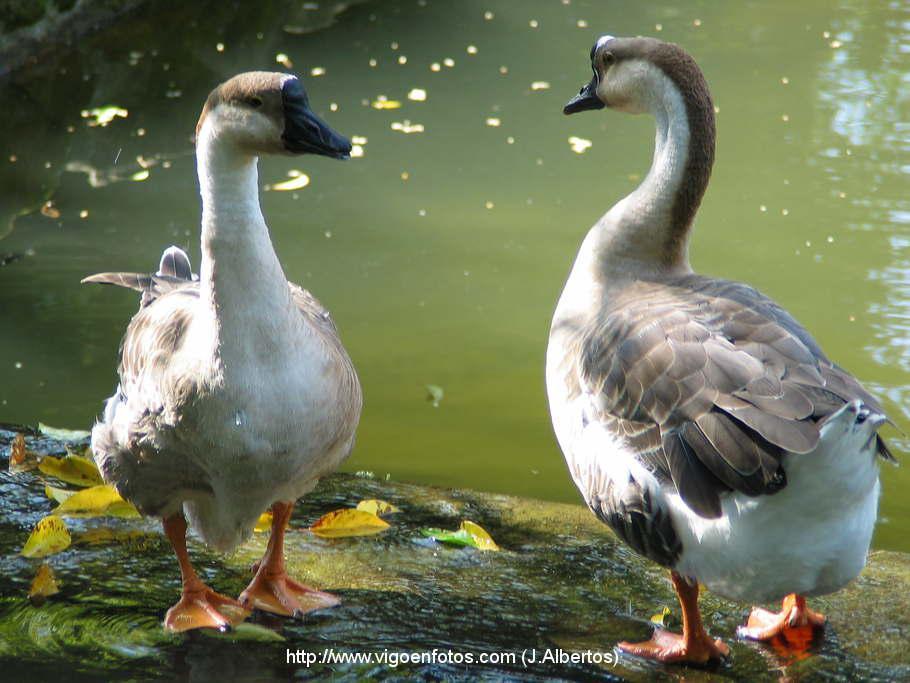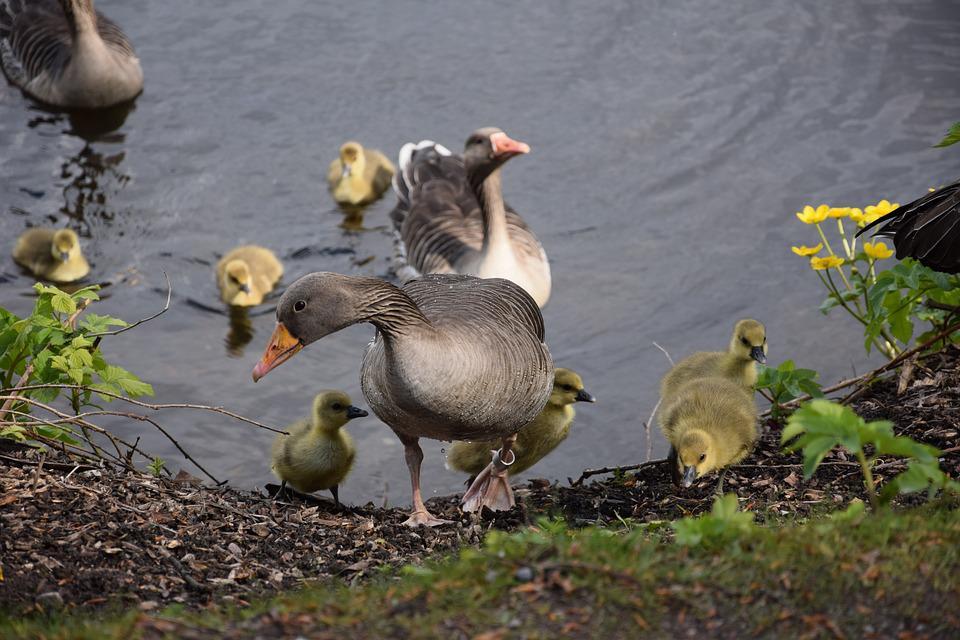The first image is the image on the left, the second image is the image on the right. Considering the images on both sides, is "The right image shows ducks with multiple ducklings." valid? Answer yes or no. Yes. 